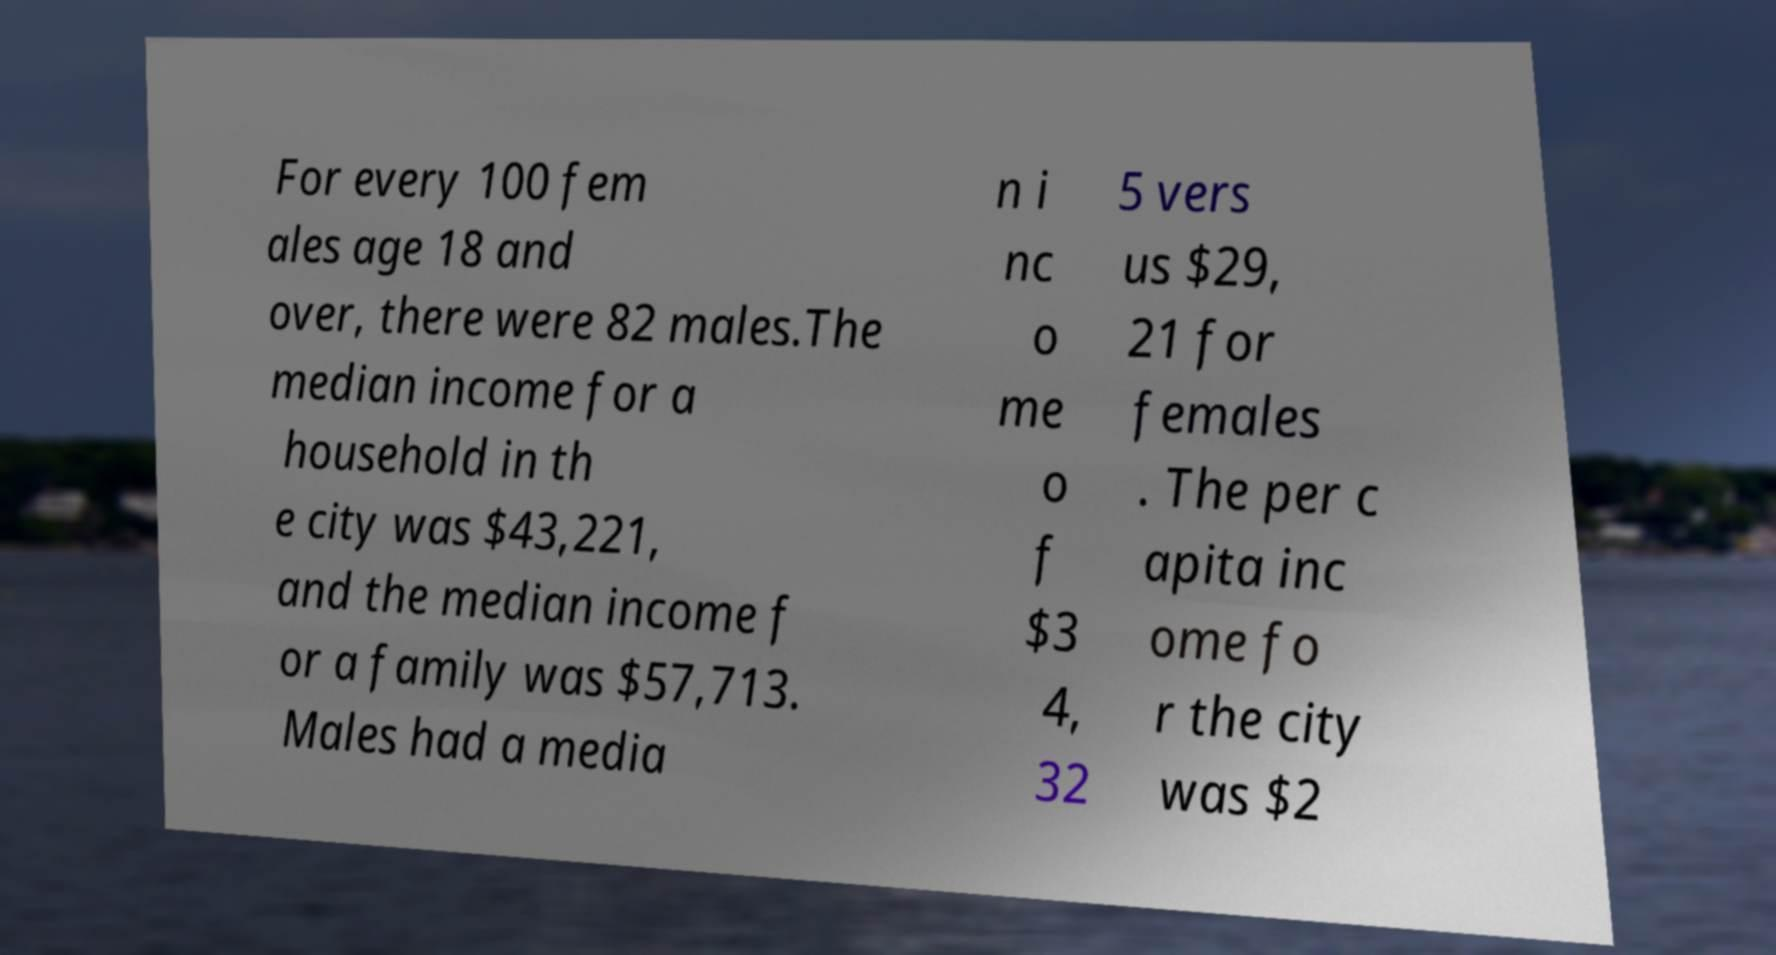What messages or text are displayed in this image? I need them in a readable, typed format. For every 100 fem ales age 18 and over, there were 82 males.The median income for a household in th e city was $43,221, and the median income f or a family was $57,713. Males had a media n i nc o me o f $3 4, 32 5 vers us $29, 21 for females . The per c apita inc ome fo r the city was $2 